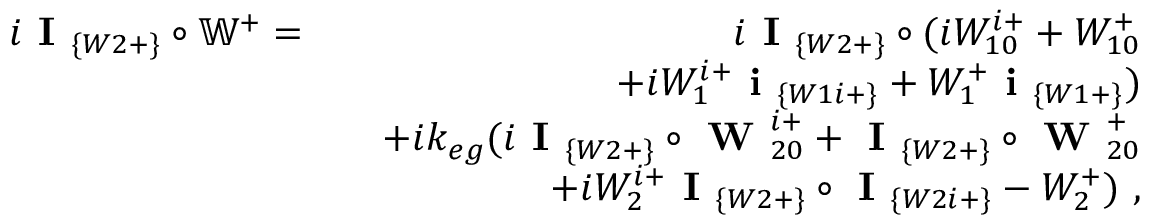<formula> <loc_0><loc_0><loc_500><loc_500>\begin{array} { r l r } { i I _ { \{ W 2 + \} } \circ \mathbb { W } ^ { + } = } & { i I _ { \{ W 2 + \} } \circ ( i W _ { 1 0 } ^ { i + } + W _ { 1 0 } ^ { + } } \\ & { + i W _ { 1 } ^ { i + } i _ { \{ W 1 i + \} } + W _ { 1 } ^ { + } i _ { \{ W 1 + \} } ) } \\ & { + i k _ { e g } ( i I _ { \{ W 2 + \} } \circ W _ { 2 0 } ^ { i + } + I _ { \{ W 2 + \} } \circ W _ { 2 0 } ^ { + } } \\ & { + i W _ { 2 } ^ { i + } I _ { \{ W 2 + \} } \circ I _ { \{ W 2 i + \} } - W _ { 2 } ^ { + } ) , } \end{array}</formula> 